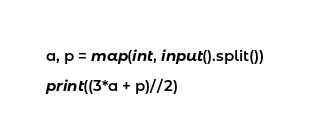<code> <loc_0><loc_0><loc_500><loc_500><_Python_>a, p = map(int, input().split())

print((3*a + p)//2)</code> 